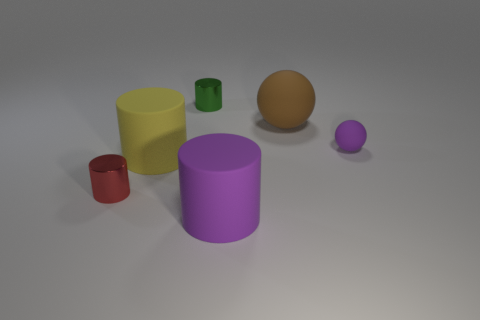How many big objects are yellow metallic things or purple matte balls?
Ensure brevity in your answer.  0. There is a rubber object in front of the yellow thing; is it the same shape as the purple matte thing that is to the right of the big purple rubber cylinder?
Your response must be concise. No. There is a shiny cylinder that is behind the thing left of the large matte cylinder behind the red object; what is its size?
Provide a succinct answer. Small. What size is the object that is behind the brown matte thing?
Provide a short and direct response. Small. What material is the large object left of the large purple rubber cylinder?
Offer a terse response. Rubber. What number of green things are matte cylinders or tiny rubber blocks?
Provide a succinct answer. 0. Are the big yellow thing and the tiny thing on the right side of the green cylinder made of the same material?
Provide a succinct answer. Yes. Are there the same number of tiny green shiny things in front of the small purple sphere and big purple rubber cylinders that are behind the large yellow rubber cylinder?
Provide a succinct answer. Yes. Is the size of the green cylinder the same as the purple thing on the left side of the tiny purple object?
Make the answer very short. No. Are there more small red cylinders to the right of the purple matte sphere than large yellow rubber things?
Provide a succinct answer. No. 